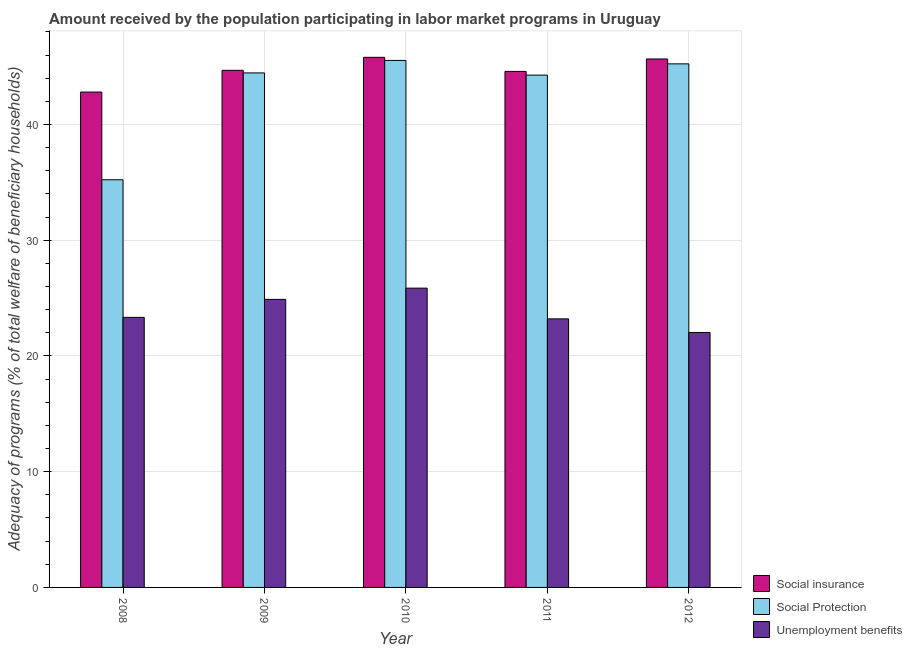How many groups of bars are there?
Offer a terse response. 5. Are the number of bars per tick equal to the number of legend labels?
Your response must be concise. Yes. How many bars are there on the 3rd tick from the right?
Make the answer very short. 3. What is the label of the 4th group of bars from the left?
Provide a short and direct response. 2011. In how many cases, is the number of bars for a given year not equal to the number of legend labels?
Offer a very short reply. 0. What is the amount received by the population participating in social protection programs in 2008?
Provide a short and direct response. 35.22. Across all years, what is the maximum amount received by the population participating in unemployment benefits programs?
Keep it short and to the point. 25.86. Across all years, what is the minimum amount received by the population participating in social insurance programs?
Your answer should be compact. 42.8. In which year was the amount received by the population participating in social protection programs minimum?
Offer a terse response. 2008. What is the total amount received by the population participating in social insurance programs in the graph?
Provide a short and direct response. 223.52. What is the difference between the amount received by the population participating in social protection programs in 2008 and that in 2011?
Your answer should be very brief. -9.04. What is the difference between the amount received by the population participating in unemployment benefits programs in 2008 and the amount received by the population participating in social protection programs in 2009?
Give a very brief answer. -1.55. What is the average amount received by the population participating in social insurance programs per year?
Your answer should be very brief. 44.7. In how many years, is the amount received by the population participating in social protection programs greater than 8 %?
Give a very brief answer. 5. What is the ratio of the amount received by the population participating in unemployment benefits programs in 2010 to that in 2011?
Offer a very short reply. 1.11. Is the amount received by the population participating in social insurance programs in 2010 less than that in 2012?
Keep it short and to the point. No. What is the difference between the highest and the second highest amount received by the population participating in social protection programs?
Offer a terse response. 0.3. What is the difference between the highest and the lowest amount received by the population participating in social protection programs?
Offer a terse response. 10.31. Is the sum of the amount received by the population participating in social insurance programs in 2008 and 2010 greater than the maximum amount received by the population participating in social protection programs across all years?
Keep it short and to the point. Yes. What does the 2nd bar from the left in 2011 represents?
Keep it short and to the point. Social Protection. What does the 1st bar from the right in 2009 represents?
Keep it short and to the point. Unemployment benefits. Are all the bars in the graph horizontal?
Your answer should be compact. No. How many years are there in the graph?
Ensure brevity in your answer.  5. What is the difference between two consecutive major ticks on the Y-axis?
Provide a succinct answer. 10. Are the values on the major ticks of Y-axis written in scientific E-notation?
Offer a very short reply. No. Does the graph contain any zero values?
Make the answer very short. No. How are the legend labels stacked?
Your answer should be compact. Vertical. What is the title of the graph?
Keep it short and to the point. Amount received by the population participating in labor market programs in Uruguay. Does "Transport equipments" appear as one of the legend labels in the graph?
Your response must be concise. No. What is the label or title of the X-axis?
Give a very brief answer. Year. What is the label or title of the Y-axis?
Offer a very short reply. Adequacy of programs (% of total welfare of beneficiary households). What is the Adequacy of programs (% of total welfare of beneficiary households) of Social insurance in 2008?
Keep it short and to the point. 42.8. What is the Adequacy of programs (% of total welfare of beneficiary households) in Social Protection in 2008?
Provide a short and direct response. 35.22. What is the Adequacy of programs (% of total welfare of beneficiary households) in Unemployment benefits in 2008?
Provide a short and direct response. 23.33. What is the Adequacy of programs (% of total welfare of beneficiary households) in Social insurance in 2009?
Provide a short and direct response. 44.68. What is the Adequacy of programs (% of total welfare of beneficiary households) in Social Protection in 2009?
Offer a very short reply. 44.45. What is the Adequacy of programs (% of total welfare of beneficiary households) of Unemployment benefits in 2009?
Offer a terse response. 24.89. What is the Adequacy of programs (% of total welfare of beneficiary households) in Social insurance in 2010?
Provide a succinct answer. 45.8. What is the Adequacy of programs (% of total welfare of beneficiary households) in Social Protection in 2010?
Provide a short and direct response. 45.53. What is the Adequacy of programs (% of total welfare of beneficiary households) of Unemployment benefits in 2010?
Provide a succinct answer. 25.86. What is the Adequacy of programs (% of total welfare of beneficiary households) of Social insurance in 2011?
Offer a terse response. 44.58. What is the Adequacy of programs (% of total welfare of beneficiary households) in Social Protection in 2011?
Provide a succinct answer. 44.26. What is the Adequacy of programs (% of total welfare of beneficiary households) of Unemployment benefits in 2011?
Give a very brief answer. 23.2. What is the Adequacy of programs (% of total welfare of beneficiary households) of Social insurance in 2012?
Make the answer very short. 45.66. What is the Adequacy of programs (% of total welfare of beneficiary households) of Social Protection in 2012?
Offer a very short reply. 45.24. What is the Adequacy of programs (% of total welfare of beneficiary households) in Unemployment benefits in 2012?
Your response must be concise. 22.03. Across all years, what is the maximum Adequacy of programs (% of total welfare of beneficiary households) in Social insurance?
Keep it short and to the point. 45.8. Across all years, what is the maximum Adequacy of programs (% of total welfare of beneficiary households) of Social Protection?
Keep it short and to the point. 45.53. Across all years, what is the maximum Adequacy of programs (% of total welfare of beneficiary households) of Unemployment benefits?
Your answer should be compact. 25.86. Across all years, what is the minimum Adequacy of programs (% of total welfare of beneficiary households) in Social insurance?
Ensure brevity in your answer.  42.8. Across all years, what is the minimum Adequacy of programs (% of total welfare of beneficiary households) of Social Protection?
Offer a terse response. 35.22. Across all years, what is the minimum Adequacy of programs (% of total welfare of beneficiary households) of Unemployment benefits?
Your response must be concise. 22.03. What is the total Adequacy of programs (% of total welfare of beneficiary households) of Social insurance in the graph?
Your answer should be compact. 223.52. What is the total Adequacy of programs (% of total welfare of beneficiary households) in Social Protection in the graph?
Your answer should be very brief. 214.71. What is the total Adequacy of programs (% of total welfare of beneficiary households) in Unemployment benefits in the graph?
Keep it short and to the point. 119.31. What is the difference between the Adequacy of programs (% of total welfare of beneficiary households) of Social insurance in 2008 and that in 2009?
Offer a terse response. -1.88. What is the difference between the Adequacy of programs (% of total welfare of beneficiary households) of Social Protection in 2008 and that in 2009?
Your response must be concise. -9.23. What is the difference between the Adequacy of programs (% of total welfare of beneficiary households) in Unemployment benefits in 2008 and that in 2009?
Offer a terse response. -1.55. What is the difference between the Adequacy of programs (% of total welfare of beneficiary households) of Social insurance in 2008 and that in 2010?
Keep it short and to the point. -3. What is the difference between the Adequacy of programs (% of total welfare of beneficiary households) in Social Protection in 2008 and that in 2010?
Provide a short and direct response. -10.31. What is the difference between the Adequacy of programs (% of total welfare of beneficiary households) in Unemployment benefits in 2008 and that in 2010?
Offer a very short reply. -2.53. What is the difference between the Adequacy of programs (% of total welfare of beneficiary households) of Social insurance in 2008 and that in 2011?
Provide a succinct answer. -1.78. What is the difference between the Adequacy of programs (% of total welfare of beneficiary households) in Social Protection in 2008 and that in 2011?
Provide a succinct answer. -9.04. What is the difference between the Adequacy of programs (% of total welfare of beneficiary households) in Unemployment benefits in 2008 and that in 2011?
Offer a terse response. 0.13. What is the difference between the Adequacy of programs (% of total welfare of beneficiary households) of Social insurance in 2008 and that in 2012?
Provide a short and direct response. -2.86. What is the difference between the Adequacy of programs (% of total welfare of beneficiary households) in Social Protection in 2008 and that in 2012?
Keep it short and to the point. -10.01. What is the difference between the Adequacy of programs (% of total welfare of beneficiary households) of Unemployment benefits in 2008 and that in 2012?
Your answer should be very brief. 1.3. What is the difference between the Adequacy of programs (% of total welfare of beneficiary households) in Social insurance in 2009 and that in 2010?
Offer a terse response. -1.12. What is the difference between the Adequacy of programs (% of total welfare of beneficiary households) in Social Protection in 2009 and that in 2010?
Provide a short and direct response. -1.08. What is the difference between the Adequacy of programs (% of total welfare of beneficiary households) in Unemployment benefits in 2009 and that in 2010?
Keep it short and to the point. -0.97. What is the difference between the Adequacy of programs (% of total welfare of beneficiary households) in Social insurance in 2009 and that in 2011?
Offer a terse response. 0.09. What is the difference between the Adequacy of programs (% of total welfare of beneficiary households) of Social Protection in 2009 and that in 2011?
Offer a very short reply. 0.19. What is the difference between the Adequacy of programs (% of total welfare of beneficiary households) of Unemployment benefits in 2009 and that in 2011?
Offer a very short reply. 1.68. What is the difference between the Adequacy of programs (% of total welfare of beneficiary households) in Social insurance in 2009 and that in 2012?
Your response must be concise. -0.98. What is the difference between the Adequacy of programs (% of total welfare of beneficiary households) in Social Protection in 2009 and that in 2012?
Your response must be concise. -0.78. What is the difference between the Adequacy of programs (% of total welfare of beneficiary households) of Unemployment benefits in 2009 and that in 2012?
Your answer should be compact. 2.86. What is the difference between the Adequacy of programs (% of total welfare of beneficiary households) of Social insurance in 2010 and that in 2011?
Your answer should be compact. 1.22. What is the difference between the Adequacy of programs (% of total welfare of beneficiary households) of Social Protection in 2010 and that in 2011?
Offer a very short reply. 1.27. What is the difference between the Adequacy of programs (% of total welfare of beneficiary households) of Unemployment benefits in 2010 and that in 2011?
Give a very brief answer. 2.65. What is the difference between the Adequacy of programs (% of total welfare of beneficiary households) of Social insurance in 2010 and that in 2012?
Your response must be concise. 0.14. What is the difference between the Adequacy of programs (% of total welfare of beneficiary households) of Social Protection in 2010 and that in 2012?
Keep it short and to the point. 0.3. What is the difference between the Adequacy of programs (% of total welfare of beneficiary households) of Unemployment benefits in 2010 and that in 2012?
Provide a succinct answer. 3.83. What is the difference between the Adequacy of programs (% of total welfare of beneficiary households) of Social insurance in 2011 and that in 2012?
Give a very brief answer. -1.08. What is the difference between the Adequacy of programs (% of total welfare of beneficiary households) of Social Protection in 2011 and that in 2012?
Keep it short and to the point. -0.97. What is the difference between the Adequacy of programs (% of total welfare of beneficiary households) in Unemployment benefits in 2011 and that in 2012?
Your answer should be very brief. 1.17. What is the difference between the Adequacy of programs (% of total welfare of beneficiary households) in Social insurance in 2008 and the Adequacy of programs (% of total welfare of beneficiary households) in Social Protection in 2009?
Your answer should be very brief. -1.65. What is the difference between the Adequacy of programs (% of total welfare of beneficiary households) in Social insurance in 2008 and the Adequacy of programs (% of total welfare of beneficiary households) in Unemployment benefits in 2009?
Ensure brevity in your answer.  17.91. What is the difference between the Adequacy of programs (% of total welfare of beneficiary households) of Social Protection in 2008 and the Adequacy of programs (% of total welfare of beneficiary households) of Unemployment benefits in 2009?
Ensure brevity in your answer.  10.34. What is the difference between the Adequacy of programs (% of total welfare of beneficiary households) in Social insurance in 2008 and the Adequacy of programs (% of total welfare of beneficiary households) in Social Protection in 2010?
Provide a short and direct response. -2.73. What is the difference between the Adequacy of programs (% of total welfare of beneficiary households) in Social insurance in 2008 and the Adequacy of programs (% of total welfare of beneficiary households) in Unemployment benefits in 2010?
Keep it short and to the point. 16.94. What is the difference between the Adequacy of programs (% of total welfare of beneficiary households) of Social Protection in 2008 and the Adequacy of programs (% of total welfare of beneficiary households) of Unemployment benefits in 2010?
Offer a very short reply. 9.36. What is the difference between the Adequacy of programs (% of total welfare of beneficiary households) in Social insurance in 2008 and the Adequacy of programs (% of total welfare of beneficiary households) in Social Protection in 2011?
Keep it short and to the point. -1.46. What is the difference between the Adequacy of programs (% of total welfare of beneficiary households) in Social insurance in 2008 and the Adequacy of programs (% of total welfare of beneficiary households) in Unemployment benefits in 2011?
Provide a succinct answer. 19.6. What is the difference between the Adequacy of programs (% of total welfare of beneficiary households) in Social Protection in 2008 and the Adequacy of programs (% of total welfare of beneficiary households) in Unemployment benefits in 2011?
Your response must be concise. 12.02. What is the difference between the Adequacy of programs (% of total welfare of beneficiary households) of Social insurance in 2008 and the Adequacy of programs (% of total welfare of beneficiary households) of Social Protection in 2012?
Keep it short and to the point. -2.44. What is the difference between the Adequacy of programs (% of total welfare of beneficiary households) in Social insurance in 2008 and the Adequacy of programs (% of total welfare of beneficiary households) in Unemployment benefits in 2012?
Make the answer very short. 20.77. What is the difference between the Adequacy of programs (% of total welfare of beneficiary households) in Social Protection in 2008 and the Adequacy of programs (% of total welfare of beneficiary households) in Unemployment benefits in 2012?
Your response must be concise. 13.19. What is the difference between the Adequacy of programs (% of total welfare of beneficiary households) of Social insurance in 2009 and the Adequacy of programs (% of total welfare of beneficiary households) of Social Protection in 2010?
Provide a short and direct response. -0.85. What is the difference between the Adequacy of programs (% of total welfare of beneficiary households) of Social insurance in 2009 and the Adequacy of programs (% of total welfare of beneficiary households) of Unemployment benefits in 2010?
Your response must be concise. 18.82. What is the difference between the Adequacy of programs (% of total welfare of beneficiary households) in Social Protection in 2009 and the Adequacy of programs (% of total welfare of beneficiary households) in Unemployment benefits in 2010?
Your answer should be compact. 18.6. What is the difference between the Adequacy of programs (% of total welfare of beneficiary households) in Social insurance in 2009 and the Adequacy of programs (% of total welfare of beneficiary households) in Social Protection in 2011?
Ensure brevity in your answer.  0.41. What is the difference between the Adequacy of programs (% of total welfare of beneficiary households) in Social insurance in 2009 and the Adequacy of programs (% of total welfare of beneficiary households) in Unemployment benefits in 2011?
Your answer should be compact. 21.47. What is the difference between the Adequacy of programs (% of total welfare of beneficiary households) in Social Protection in 2009 and the Adequacy of programs (% of total welfare of beneficiary households) in Unemployment benefits in 2011?
Provide a succinct answer. 21.25. What is the difference between the Adequacy of programs (% of total welfare of beneficiary households) of Social insurance in 2009 and the Adequacy of programs (% of total welfare of beneficiary households) of Social Protection in 2012?
Provide a short and direct response. -0.56. What is the difference between the Adequacy of programs (% of total welfare of beneficiary households) of Social insurance in 2009 and the Adequacy of programs (% of total welfare of beneficiary households) of Unemployment benefits in 2012?
Make the answer very short. 22.65. What is the difference between the Adequacy of programs (% of total welfare of beneficiary households) in Social Protection in 2009 and the Adequacy of programs (% of total welfare of beneficiary households) in Unemployment benefits in 2012?
Your answer should be compact. 22.42. What is the difference between the Adequacy of programs (% of total welfare of beneficiary households) in Social insurance in 2010 and the Adequacy of programs (% of total welfare of beneficiary households) in Social Protection in 2011?
Your answer should be compact. 1.54. What is the difference between the Adequacy of programs (% of total welfare of beneficiary households) in Social insurance in 2010 and the Adequacy of programs (% of total welfare of beneficiary households) in Unemployment benefits in 2011?
Offer a terse response. 22.6. What is the difference between the Adequacy of programs (% of total welfare of beneficiary households) in Social Protection in 2010 and the Adequacy of programs (% of total welfare of beneficiary households) in Unemployment benefits in 2011?
Offer a very short reply. 22.33. What is the difference between the Adequacy of programs (% of total welfare of beneficiary households) of Social insurance in 2010 and the Adequacy of programs (% of total welfare of beneficiary households) of Social Protection in 2012?
Your response must be concise. 0.56. What is the difference between the Adequacy of programs (% of total welfare of beneficiary households) of Social insurance in 2010 and the Adequacy of programs (% of total welfare of beneficiary households) of Unemployment benefits in 2012?
Your response must be concise. 23.77. What is the difference between the Adequacy of programs (% of total welfare of beneficiary households) in Social Protection in 2010 and the Adequacy of programs (% of total welfare of beneficiary households) in Unemployment benefits in 2012?
Ensure brevity in your answer.  23.5. What is the difference between the Adequacy of programs (% of total welfare of beneficiary households) of Social insurance in 2011 and the Adequacy of programs (% of total welfare of beneficiary households) of Social Protection in 2012?
Provide a short and direct response. -0.65. What is the difference between the Adequacy of programs (% of total welfare of beneficiary households) of Social insurance in 2011 and the Adequacy of programs (% of total welfare of beneficiary households) of Unemployment benefits in 2012?
Offer a very short reply. 22.55. What is the difference between the Adequacy of programs (% of total welfare of beneficiary households) of Social Protection in 2011 and the Adequacy of programs (% of total welfare of beneficiary households) of Unemployment benefits in 2012?
Ensure brevity in your answer.  22.23. What is the average Adequacy of programs (% of total welfare of beneficiary households) of Social insurance per year?
Give a very brief answer. 44.7. What is the average Adequacy of programs (% of total welfare of beneficiary households) of Social Protection per year?
Offer a very short reply. 42.94. What is the average Adequacy of programs (% of total welfare of beneficiary households) of Unemployment benefits per year?
Your response must be concise. 23.86. In the year 2008, what is the difference between the Adequacy of programs (% of total welfare of beneficiary households) of Social insurance and Adequacy of programs (% of total welfare of beneficiary households) of Social Protection?
Your answer should be compact. 7.58. In the year 2008, what is the difference between the Adequacy of programs (% of total welfare of beneficiary households) in Social insurance and Adequacy of programs (% of total welfare of beneficiary households) in Unemployment benefits?
Give a very brief answer. 19.47. In the year 2008, what is the difference between the Adequacy of programs (% of total welfare of beneficiary households) of Social Protection and Adequacy of programs (% of total welfare of beneficiary households) of Unemployment benefits?
Offer a terse response. 11.89. In the year 2009, what is the difference between the Adequacy of programs (% of total welfare of beneficiary households) of Social insurance and Adequacy of programs (% of total welfare of beneficiary households) of Social Protection?
Your answer should be very brief. 0.22. In the year 2009, what is the difference between the Adequacy of programs (% of total welfare of beneficiary households) of Social insurance and Adequacy of programs (% of total welfare of beneficiary households) of Unemployment benefits?
Give a very brief answer. 19.79. In the year 2009, what is the difference between the Adequacy of programs (% of total welfare of beneficiary households) of Social Protection and Adequacy of programs (% of total welfare of beneficiary households) of Unemployment benefits?
Offer a very short reply. 19.57. In the year 2010, what is the difference between the Adequacy of programs (% of total welfare of beneficiary households) in Social insurance and Adequacy of programs (% of total welfare of beneficiary households) in Social Protection?
Ensure brevity in your answer.  0.27. In the year 2010, what is the difference between the Adequacy of programs (% of total welfare of beneficiary households) in Social insurance and Adequacy of programs (% of total welfare of beneficiary households) in Unemployment benefits?
Provide a succinct answer. 19.94. In the year 2010, what is the difference between the Adequacy of programs (% of total welfare of beneficiary households) in Social Protection and Adequacy of programs (% of total welfare of beneficiary households) in Unemployment benefits?
Give a very brief answer. 19.67. In the year 2011, what is the difference between the Adequacy of programs (% of total welfare of beneficiary households) in Social insurance and Adequacy of programs (% of total welfare of beneficiary households) in Social Protection?
Provide a succinct answer. 0.32. In the year 2011, what is the difference between the Adequacy of programs (% of total welfare of beneficiary households) in Social insurance and Adequacy of programs (% of total welfare of beneficiary households) in Unemployment benefits?
Your response must be concise. 21.38. In the year 2011, what is the difference between the Adequacy of programs (% of total welfare of beneficiary households) of Social Protection and Adequacy of programs (% of total welfare of beneficiary households) of Unemployment benefits?
Provide a short and direct response. 21.06. In the year 2012, what is the difference between the Adequacy of programs (% of total welfare of beneficiary households) in Social insurance and Adequacy of programs (% of total welfare of beneficiary households) in Social Protection?
Give a very brief answer. 0.42. In the year 2012, what is the difference between the Adequacy of programs (% of total welfare of beneficiary households) of Social insurance and Adequacy of programs (% of total welfare of beneficiary households) of Unemployment benefits?
Ensure brevity in your answer.  23.63. In the year 2012, what is the difference between the Adequacy of programs (% of total welfare of beneficiary households) in Social Protection and Adequacy of programs (% of total welfare of beneficiary households) in Unemployment benefits?
Provide a short and direct response. 23.21. What is the ratio of the Adequacy of programs (% of total welfare of beneficiary households) in Social insurance in 2008 to that in 2009?
Give a very brief answer. 0.96. What is the ratio of the Adequacy of programs (% of total welfare of beneficiary households) in Social Protection in 2008 to that in 2009?
Your answer should be compact. 0.79. What is the ratio of the Adequacy of programs (% of total welfare of beneficiary households) of Unemployment benefits in 2008 to that in 2009?
Offer a terse response. 0.94. What is the ratio of the Adequacy of programs (% of total welfare of beneficiary households) in Social insurance in 2008 to that in 2010?
Make the answer very short. 0.93. What is the ratio of the Adequacy of programs (% of total welfare of beneficiary households) in Social Protection in 2008 to that in 2010?
Provide a succinct answer. 0.77. What is the ratio of the Adequacy of programs (% of total welfare of beneficiary households) in Unemployment benefits in 2008 to that in 2010?
Provide a succinct answer. 0.9. What is the ratio of the Adequacy of programs (% of total welfare of beneficiary households) of Social Protection in 2008 to that in 2011?
Offer a terse response. 0.8. What is the ratio of the Adequacy of programs (% of total welfare of beneficiary households) in Unemployment benefits in 2008 to that in 2011?
Keep it short and to the point. 1.01. What is the ratio of the Adequacy of programs (% of total welfare of beneficiary households) in Social insurance in 2008 to that in 2012?
Your answer should be compact. 0.94. What is the ratio of the Adequacy of programs (% of total welfare of beneficiary households) of Social Protection in 2008 to that in 2012?
Provide a succinct answer. 0.78. What is the ratio of the Adequacy of programs (% of total welfare of beneficiary households) of Unemployment benefits in 2008 to that in 2012?
Ensure brevity in your answer.  1.06. What is the ratio of the Adequacy of programs (% of total welfare of beneficiary households) in Social insurance in 2009 to that in 2010?
Keep it short and to the point. 0.98. What is the ratio of the Adequacy of programs (% of total welfare of beneficiary households) in Social Protection in 2009 to that in 2010?
Provide a succinct answer. 0.98. What is the ratio of the Adequacy of programs (% of total welfare of beneficiary households) in Unemployment benefits in 2009 to that in 2010?
Ensure brevity in your answer.  0.96. What is the ratio of the Adequacy of programs (% of total welfare of beneficiary households) in Social insurance in 2009 to that in 2011?
Provide a succinct answer. 1. What is the ratio of the Adequacy of programs (% of total welfare of beneficiary households) of Social Protection in 2009 to that in 2011?
Ensure brevity in your answer.  1. What is the ratio of the Adequacy of programs (% of total welfare of beneficiary households) of Unemployment benefits in 2009 to that in 2011?
Provide a short and direct response. 1.07. What is the ratio of the Adequacy of programs (% of total welfare of beneficiary households) in Social insurance in 2009 to that in 2012?
Ensure brevity in your answer.  0.98. What is the ratio of the Adequacy of programs (% of total welfare of beneficiary households) in Social Protection in 2009 to that in 2012?
Offer a terse response. 0.98. What is the ratio of the Adequacy of programs (% of total welfare of beneficiary households) in Unemployment benefits in 2009 to that in 2012?
Your answer should be very brief. 1.13. What is the ratio of the Adequacy of programs (% of total welfare of beneficiary households) of Social insurance in 2010 to that in 2011?
Provide a succinct answer. 1.03. What is the ratio of the Adequacy of programs (% of total welfare of beneficiary households) in Social Protection in 2010 to that in 2011?
Offer a terse response. 1.03. What is the ratio of the Adequacy of programs (% of total welfare of beneficiary households) in Unemployment benefits in 2010 to that in 2011?
Your answer should be very brief. 1.11. What is the ratio of the Adequacy of programs (% of total welfare of beneficiary households) of Social Protection in 2010 to that in 2012?
Your answer should be very brief. 1.01. What is the ratio of the Adequacy of programs (% of total welfare of beneficiary households) of Unemployment benefits in 2010 to that in 2012?
Your response must be concise. 1.17. What is the ratio of the Adequacy of programs (% of total welfare of beneficiary households) in Social insurance in 2011 to that in 2012?
Make the answer very short. 0.98. What is the ratio of the Adequacy of programs (% of total welfare of beneficiary households) of Social Protection in 2011 to that in 2012?
Keep it short and to the point. 0.98. What is the ratio of the Adequacy of programs (% of total welfare of beneficiary households) in Unemployment benefits in 2011 to that in 2012?
Keep it short and to the point. 1.05. What is the difference between the highest and the second highest Adequacy of programs (% of total welfare of beneficiary households) of Social insurance?
Your response must be concise. 0.14. What is the difference between the highest and the second highest Adequacy of programs (% of total welfare of beneficiary households) in Social Protection?
Your answer should be very brief. 0.3. What is the difference between the highest and the second highest Adequacy of programs (% of total welfare of beneficiary households) of Unemployment benefits?
Give a very brief answer. 0.97. What is the difference between the highest and the lowest Adequacy of programs (% of total welfare of beneficiary households) in Social insurance?
Make the answer very short. 3. What is the difference between the highest and the lowest Adequacy of programs (% of total welfare of beneficiary households) of Social Protection?
Ensure brevity in your answer.  10.31. What is the difference between the highest and the lowest Adequacy of programs (% of total welfare of beneficiary households) in Unemployment benefits?
Provide a succinct answer. 3.83. 